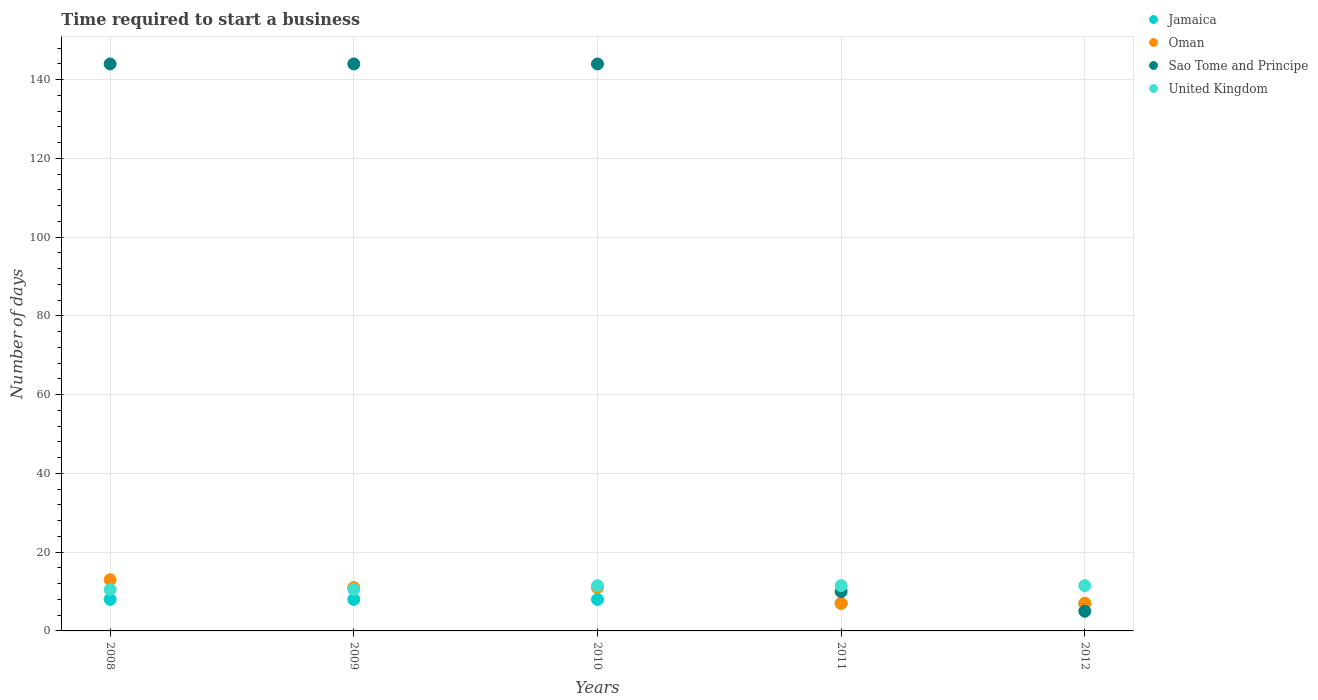What is the number of days required to start a business in Sao Tome and Principe in 2008?
Your response must be concise. 144. Across all years, what is the maximum number of days required to start a business in Oman?
Provide a succinct answer. 13. Across all years, what is the minimum number of days required to start a business in United Kingdom?
Offer a very short reply. 10.5. In which year was the number of days required to start a business in Sao Tome and Principe minimum?
Provide a succinct answer. 2012. What is the total number of days required to start a business in Sao Tome and Principe in the graph?
Your answer should be very brief. 447. What is the difference between the number of days required to start a business in Jamaica in 2008 and that in 2012?
Keep it short and to the point. 1. What is the difference between the number of days required to start a business in Jamaica in 2009 and the number of days required to start a business in Oman in 2010?
Provide a succinct answer. -3. In the year 2008, what is the difference between the number of days required to start a business in Oman and number of days required to start a business in Sao Tome and Principe?
Make the answer very short. -131. What is the ratio of the number of days required to start a business in Jamaica in 2008 to that in 2010?
Offer a terse response. 1. Is the number of days required to start a business in Oman in 2010 less than that in 2011?
Provide a short and direct response. No. What is the difference between the highest and the lowest number of days required to start a business in Jamaica?
Keep it short and to the point. 1. In how many years, is the number of days required to start a business in United Kingdom greater than the average number of days required to start a business in United Kingdom taken over all years?
Your response must be concise. 3. Is the sum of the number of days required to start a business in United Kingdom in 2009 and 2010 greater than the maximum number of days required to start a business in Jamaica across all years?
Give a very brief answer. Yes. Is it the case that in every year, the sum of the number of days required to start a business in Oman and number of days required to start a business in United Kingdom  is greater than the number of days required to start a business in Sao Tome and Principe?
Your answer should be very brief. No. Does the number of days required to start a business in Sao Tome and Principe monotonically increase over the years?
Your answer should be compact. No. Is the number of days required to start a business in Oman strictly greater than the number of days required to start a business in Jamaica over the years?
Make the answer very short. No. How many years are there in the graph?
Keep it short and to the point. 5. What is the difference between two consecutive major ticks on the Y-axis?
Offer a very short reply. 20. What is the title of the graph?
Provide a succinct answer. Time required to start a business. Does "Upper middle income" appear as one of the legend labels in the graph?
Offer a terse response. No. What is the label or title of the X-axis?
Ensure brevity in your answer.  Years. What is the label or title of the Y-axis?
Your answer should be compact. Number of days. What is the Number of days in Oman in 2008?
Give a very brief answer. 13. What is the Number of days in Sao Tome and Principe in 2008?
Keep it short and to the point. 144. What is the Number of days in Jamaica in 2009?
Your answer should be very brief. 8. What is the Number of days of Sao Tome and Principe in 2009?
Your answer should be compact. 144. What is the Number of days of Sao Tome and Principe in 2010?
Ensure brevity in your answer.  144. What is the Number of days in United Kingdom in 2010?
Provide a succinct answer. 11.5. What is the Number of days in Jamaica in 2011?
Ensure brevity in your answer.  7. What is the Number of days in Oman in 2011?
Your answer should be very brief. 7. What is the Number of days of Sao Tome and Principe in 2011?
Offer a very short reply. 10. What is the Number of days of United Kingdom in 2011?
Give a very brief answer. 11.5. What is the Number of days of United Kingdom in 2012?
Offer a terse response. 11.5. Across all years, what is the maximum Number of days of Sao Tome and Principe?
Your answer should be very brief. 144. Across all years, what is the minimum Number of days of Jamaica?
Offer a terse response. 7. Across all years, what is the minimum Number of days of United Kingdom?
Your response must be concise. 10.5. What is the total Number of days of Sao Tome and Principe in the graph?
Provide a succinct answer. 447. What is the total Number of days in United Kingdom in the graph?
Provide a succinct answer. 55.5. What is the difference between the Number of days of Jamaica in 2008 and that in 2009?
Offer a very short reply. 0. What is the difference between the Number of days of Sao Tome and Principe in 2008 and that in 2009?
Keep it short and to the point. 0. What is the difference between the Number of days of Jamaica in 2008 and that in 2010?
Offer a very short reply. 0. What is the difference between the Number of days in United Kingdom in 2008 and that in 2010?
Ensure brevity in your answer.  -1. What is the difference between the Number of days of Jamaica in 2008 and that in 2011?
Your response must be concise. 1. What is the difference between the Number of days in Oman in 2008 and that in 2011?
Your answer should be compact. 6. What is the difference between the Number of days in Sao Tome and Principe in 2008 and that in 2011?
Provide a short and direct response. 134. What is the difference between the Number of days in Oman in 2008 and that in 2012?
Ensure brevity in your answer.  6. What is the difference between the Number of days of Sao Tome and Principe in 2008 and that in 2012?
Make the answer very short. 139. What is the difference between the Number of days in United Kingdom in 2008 and that in 2012?
Your answer should be compact. -1. What is the difference between the Number of days of Sao Tome and Principe in 2009 and that in 2011?
Offer a very short reply. 134. What is the difference between the Number of days in Sao Tome and Principe in 2009 and that in 2012?
Your answer should be compact. 139. What is the difference between the Number of days of United Kingdom in 2009 and that in 2012?
Ensure brevity in your answer.  -1. What is the difference between the Number of days of Jamaica in 2010 and that in 2011?
Offer a very short reply. 1. What is the difference between the Number of days of Sao Tome and Principe in 2010 and that in 2011?
Offer a terse response. 134. What is the difference between the Number of days of United Kingdom in 2010 and that in 2011?
Keep it short and to the point. 0. What is the difference between the Number of days of Oman in 2010 and that in 2012?
Your answer should be very brief. 4. What is the difference between the Number of days in Sao Tome and Principe in 2010 and that in 2012?
Your answer should be compact. 139. What is the difference between the Number of days in Jamaica in 2011 and that in 2012?
Make the answer very short. 0. What is the difference between the Number of days of Sao Tome and Principe in 2011 and that in 2012?
Provide a short and direct response. 5. What is the difference between the Number of days in United Kingdom in 2011 and that in 2012?
Provide a succinct answer. 0. What is the difference between the Number of days of Jamaica in 2008 and the Number of days of Sao Tome and Principe in 2009?
Offer a terse response. -136. What is the difference between the Number of days in Oman in 2008 and the Number of days in Sao Tome and Principe in 2009?
Ensure brevity in your answer.  -131. What is the difference between the Number of days in Sao Tome and Principe in 2008 and the Number of days in United Kingdom in 2009?
Offer a terse response. 133.5. What is the difference between the Number of days of Jamaica in 2008 and the Number of days of Oman in 2010?
Offer a very short reply. -3. What is the difference between the Number of days in Jamaica in 2008 and the Number of days in Sao Tome and Principe in 2010?
Your answer should be very brief. -136. What is the difference between the Number of days in Oman in 2008 and the Number of days in Sao Tome and Principe in 2010?
Provide a short and direct response. -131. What is the difference between the Number of days in Oman in 2008 and the Number of days in United Kingdom in 2010?
Your response must be concise. 1.5. What is the difference between the Number of days of Sao Tome and Principe in 2008 and the Number of days of United Kingdom in 2010?
Offer a very short reply. 132.5. What is the difference between the Number of days of Jamaica in 2008 and the Number of days of Oman in 2011?
Your response must be concise. 1. What is the difference between the Number of days of Oman in 2008 and the Number of days of Sao Tome and Principe in 2011?
Your answer should be compact. 3. What is the difference between the Number of days of Sao Tome and Principe in 2008 and the Number of days of United Kingdom in 2011?
Provide a short and direct response. 132.5. What is the difference between the Number of days in Jamaica in 2008 and the Number of days in Sao Tome and Principe in 2012?
Keep it short and to the point. 3. What is the difference between the Number of days of Jamaica in 2008 and the Number of days of United Kingdom in 2012?
Your answer should be very brief. -3.5. What is the difference between the Number of days of Oman in 2008 and the Number of days of United Kingdom in 2012?
Your answer should be compact. 1.5. What is the difference between the Number of days in Sao Tome and Principe in 2008 and the Number of days in United Kingdom in 2012?
Offer a very short reply. 132.5. What is the difference between the Number of days in Jamaica in 2009 and the Number of days in Sao Tome and Principe in 2010?
Offer a terse response. -136. What is the difference between the Number of days of Jamaica in 2009 and the Number of days of United Kingdom in 2010?
Ensure brevity in your answer.  -3.5. What is the difference between the Number of days in Oman in 2009 and the Number of days in Sao Tome and Principe in 2010?
Your answer should be compact. -133. What is the difference between the Number of days in Sao Tome and Principe in 2009 and the Number of days in United Kingdom in 2010?
Keep it short and to the point. 132.5. What is the difference between the Number of days of Jamaica in 2009 and the Number of days of United Kingdom in 2011?
Provide a succinct answer. -3.5. What is the difference between the Number of days in Oman in 2009 and the Number of days in Sao Tome and Principe in 2011?
Your answer should be very brief. 1. What is the difference between the Number of days in Sao Tome and Principe in 2009 and the Number of days in United Kingdom in 2011?
Provide a succinct answer. 132.5. What is the difference between the Number of days of Jamaica in 2009 and the Number of days of Sao Tome and Principe in 2012?
Your answer should be very brief. 3. What is the difference between the Number of days of Jamaica in 2009 and the Number of days of United Kingdom in 2012?
Offer a terse response. -3.5. What is the difference between the Number of days of Oman in 2009 and the Number of days of Sao Tome and Principe in 2012?
Give a very brief answer. 6. What is the difference between the Number of days in Oman in 2009 and the Number of days in United Kingdom in 2012?
Provide a short and direct response. -0.5. What is the difference between the Number of days of Sao Tome and Principe in 2009 and the Number of days of United Kingdom in 2012?
Offer a very short reply. 132.5. What is the difference between the Number of days in Jamaica in 2010 and the Number of days in Oman in 2011?
Provide a short and direct response. 1. What is the difference between the Number of days in Jamaica in 2010 and the Number of days in Sao Tome and Principe in 2011?
Your answer should be very brief. -2. What is the difference between the Number of days of Oman in 2010 and the Number of days of Sao Tome and Principe in 2011?
Ensure brevity in your answer.  1. What is the difference between the Number of days in Sao Tome and Principe in 2010 and the Number of days in United Kingdom in 2011?
Offer a very short reply. 132.5. What is the difference between the Number of days of Jamaica in 2010 and the Number of days of Oman in 2012?
Provide a succinct answer. 1. What is the difference between the Number of days in Oman in 2010 and the Number of days in Sao Tome and Principe in 2012?
Your response must be concise. 6. What is the difference between the Number of days in Oman in 2010 and the Number of days in United Kingdom in 2012?
Your answer should be compact. -0.5. What is the difference between the Number of days of Sao Tome and Principe in 2010 and the Number of days of United Kingdom in 2012?
Your answer should be very brief. 132.5. What is the difference between the Number of days of Jamaica in 2011 and the Number of days of Sao Tome and Principe in 2012?
Provide a succinct answer. 2. What is the average Number of days of Jamaica per year?
Give a very brief answer. 7.6. What is the average Number of days of Sao Tome and Principe per year?
Offer a very short reply. 89.4. What is the average Number of days of United Kingdom per year?
Give a very brief answer. 11.1. In the year 2008, what is the difference between the Number of days of Jamaica and Number of days of Oman?
Keep it short and to the point. -5. In the year 2008, what is the difference between the Number of days of Jamaica and Number of days of Sao Tome and Principe?
Offer a terse response. -136. In the year 2008, what is the difference between the Number of days in Jamaica and Number of days in United Kingdom?
Offer a very short reply. -2.5. In the year 2008, what is the difference between the Number of days in Oman and Number of days in Sao Tome and Principe?
Your answer should be compact. -131. In the year 2008, what is the difference between the Number of days in Oman and Number of days in United Kingdom?
Make the answer very short. 2.5. In the year 2008, what is the difference between the Number of days of Sao Tome and Principe and Number of days of United Kingdom?
Make the answer very short. 133.5. In the year 2009, what is the difference between the Number of days in Jamaica and Number of days in Oman?
Your answer should be compact. -3. In the year 2009, what is the difference between the Number of days in Jamaica and Number of days in Sao Tome and Principe?
Offer a terse response. -136. In the year 2009, what is the difference between the Number of days of Jamaica and Number of days of United Kingdom?
Give a very brief answer. -2.5. In the year 2009, what is the difference between the Number of days of Oman and Number of days of Sao Tome and Principe?
Give a very brief answer. -133. In the year 2009, what is the difference between the Number of days of Sao Tome and Principe and Number of days of United Kingdom?
Your answer should be compact. 133.5. In the year 2010, what is the difference between the Number of days of Jamaica and Number of days of Oman?
Your answer should be compact. -3. In the year 2010, what is the difference between the Number of days of Jamaica and Number of days of Sao Tome and Principe?
Offer a terse response. -136. In the year 2010, what is the difference between the Number of days in Jamaica and Number of days in United Kingdom?
Your response must be concise. -3.5. In the year 2010, what is the difference between the Number of days in Oman and Number of days in Sao Tome and Principe?
Offer a terse response. -133. In the year 2010, what is the difference between the Number of days in Oman and Number of days in United Kingdom?
Give a very brief answer. -0.5. In the year 2010, what is the difference between the Number of days of Sao Tome and Principe and Number of days of United Kingdom?
Your response must be concise. 132.5. In the year 2011, what is the difference between the Number of days in Jamaica and Number of days in Oman?
Offer a terse response. 0. In the year 2011, what is the difference between the Number of days of Jamaica and Number of days of Sao Tome and Principe?
Offer a very short reply. -3. In the year 2011, what is the difference between the Number of days in Jamaica and Number of days in United Kingdom?
Provide a succinct answer. -4.5. In the year 2011, what is the difference between the Number of days in Oman and Number of days in Sao Tome and Principe?
Provide a short and direct response. -3. In the year 2012, what is the difference between the Number of days in Jamaica and Number of days in Oman?
Offer a very short reply. 0. In the year 2012, what is the difference between the Number of days in Jamaica and Number of days in Sao Tome and Principe?
Provide a short and direct response. 2. In the year 2012, what is the difference between the Number of days in Sao Tome and Principe and Number of days in United Kingdom?
Offer a terse response. -6.5. What is the ratio of the Number of days of Jamaica in 2008 to that in 2009?
Make the answer very short. 1. What is the ratio of the Number of days in Oman in 2008 to that in 2009?
Offer a very short reply. 1.18. What is the ratio of the Number of days of United Kingdom in 2008 to that in 2009?
Offer a very short reply. 1. What is the ratio of the Number of days of Jamaica in 2008 to that in 2010?
Ensure brevity in your answer.  1. What is the ratio of the Number of days of Oman in 2008 to that in 2010?
Provide a short and direct response. 1.18. What is the ratio of the Number of days of Sao Tome and Principe in 2008 to that in 2010?
Offer a terse response. 1. What is the ratio of the Number of days of Jamaica in 2008 to that in 2011?
Provide a short and direct response. 1.14. What is the ratio of the Number of days of Oman in 2008 to that in 2011?
Ensure brevity in your answer.  1.86. What is the ratio of the Number of days in Oman in 2008 to that in 2012?
Offer a very short reply. 1.86. What is the ratio of the Number of days of Sao Tome and Principe in 2008 to that in 2012?
Your answer should be compact. 28.8. What is the ratio of the Number of days in Sao Tome and Principe in 2009 to that in 2010?
Ensure brevity in your answer.  1. What is the ratio of the Number of days in Jamaica in 2009 to that in 2011?
Your answer should be compact. 1.14. What is the ratio of the Number of days of Oman in 2009 to that in 2011?
Give a very brief answer. 1.57. What is the ratio of the Number of days of United Kingdom in 2009 to that in 2011?
Provide a succinct answer. 0.91. What is the ratio of the Number of days in Jamaica in 2009 to that in 2012?
Provide a succinct answer. 1.14. What is the ratio of the Number of days in Oman in 2009 to that in 2012?
Make the answer very short. 1.57. What is the ratio of the Number of days of Sao Tome and Principe in 2009 to that in 2012?
Your answer should be very brief. 28.8. What is the ratio of the Number of days of United Kingdom in 2009 to that in 2012?
Provide a succinct answer. 0.91. What is the ratio of the Number of days in Oman in 2010 to that in 2011?
Your answer should be very brief. 1.57. What is the ratio of the Number of days of Sao Tome and Principe in 2010 to that in 2011?
Give a very brief answer. 14.4. What is the ratio of the Number of days of Oman in 2010 to that in 2012?
Your answer should be compact. 1.57. What is the ratio of the Number of days of Sao Tome and Principe in 2010 to that in 2012?
Offer a terse response. 28.8. What is the ratio of the Number of days of Jamaica in 2011 to that in 2012?
Offer a very short reply. 1. What is the ratio of the Number of days of Sao Tome and Principe in 2011 to that in 2012?
Offer a very short reply. 2. What is the ratio of the Number of days in United Kingdom in 2011 to that in 2012?
Provide a short and direct response. 1. What is the difference between the highest and the second highest Number of days in Sao Tome and Principe?
Make the answer very short. 0. What is the difference between the highest and the lowest Number of days in Sao Tome and Principe?
Provide a succinct answer. 139. What is the difference between the highest and the lowest Number of days of United Kingdom?
Provide a succinct answer. 1. 